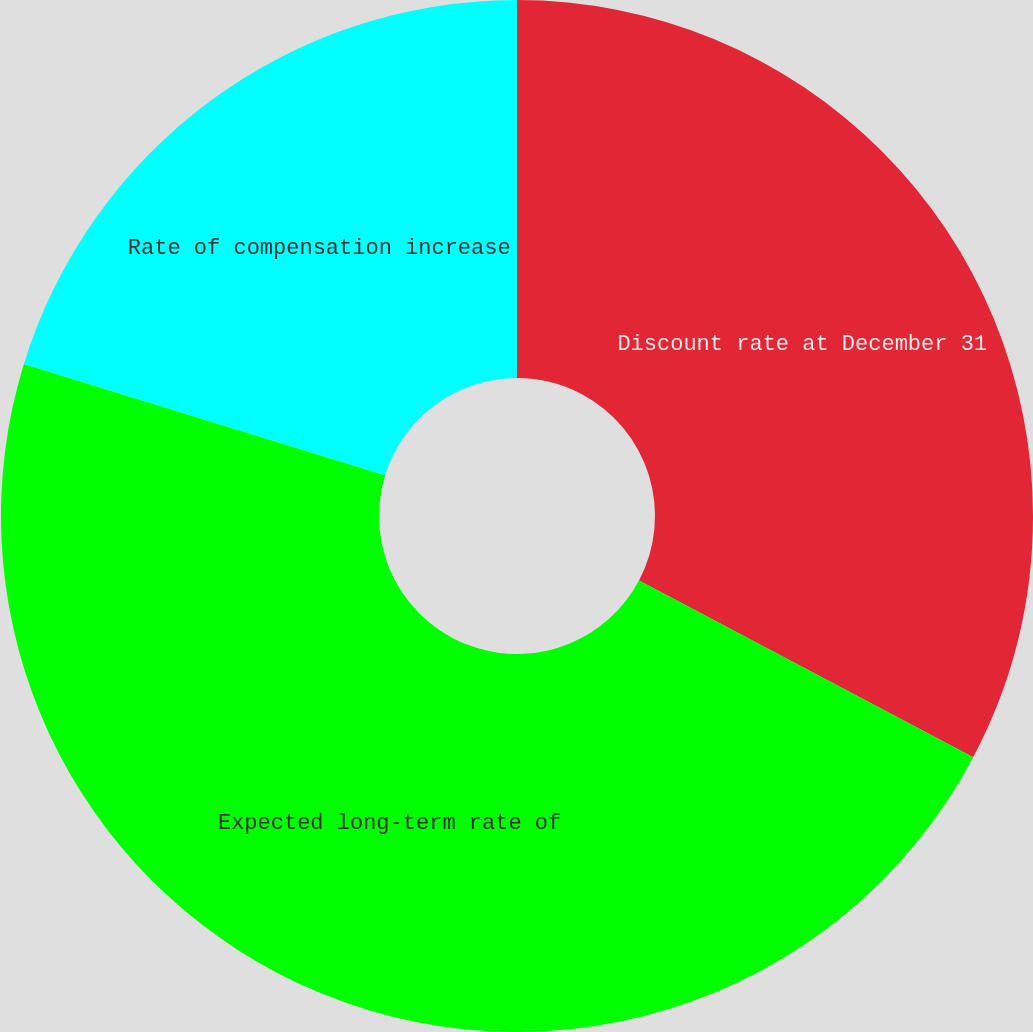Convert chart to OTSL. <chart><loc_0><loc_0><loc_500><loc_500><pie_chart><fcel>Discount rate at December 31<fcel>Expected long-term rate of<fcel>Rate of compensation increase<nl><fcel>32.74%<fcel>47.02%<fcel>20.24%<nl></chart> 